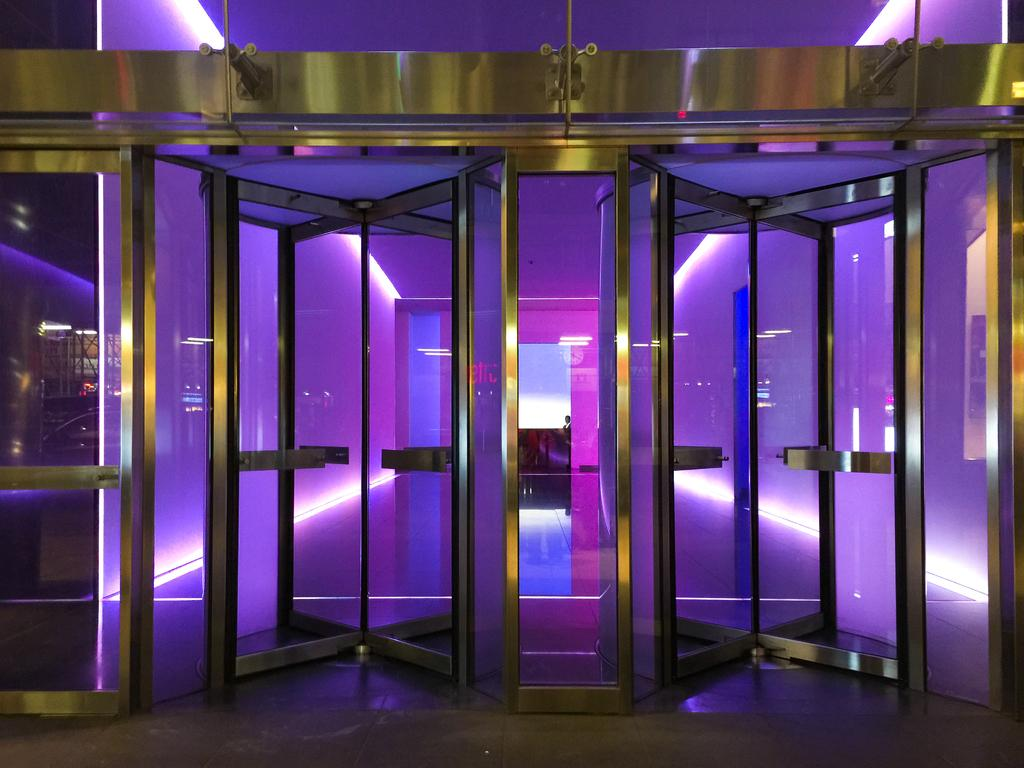How many doors are visible in the image? There are two doors in the image. What feature do the doors have? The doors have glass. Is there any lighting element associated with the doors? Yes, there is a purple light attached to the doors or nearby. Can you describe the man in the image? There is a man standing in the backdrop of the image. What type of coal is being used to heat the stove in the image? There is no stove or coal present in the image. Can you tell me how many planes are visible in the image? There are no planes visible in the image. 